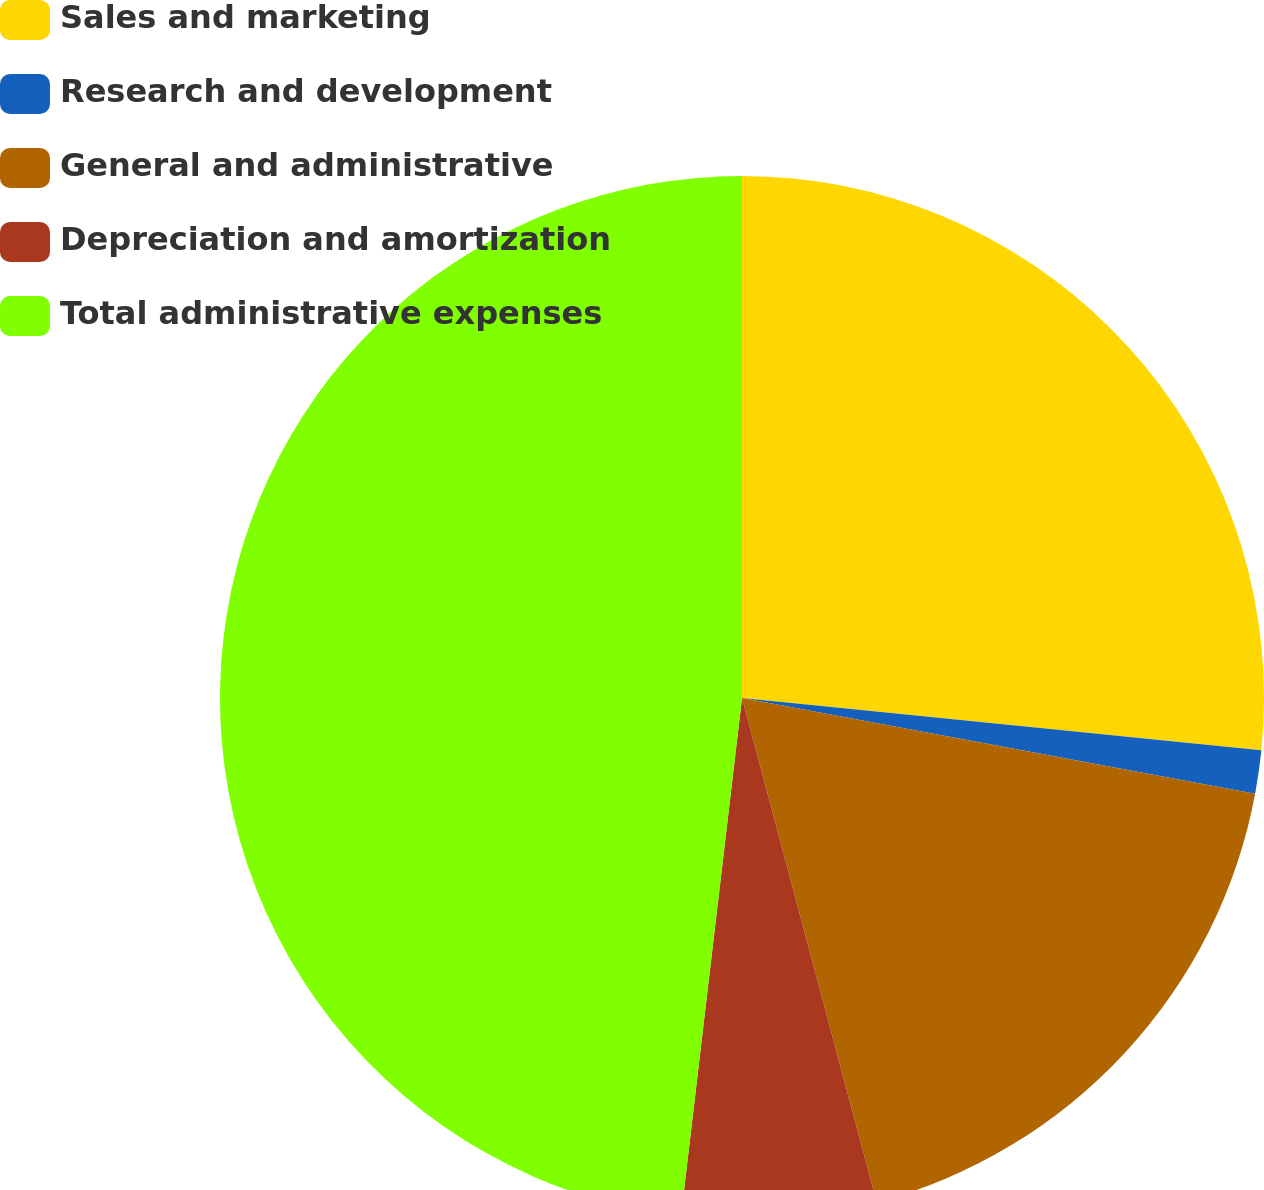Convert chart to OTSL. <chart><loc_0><loc_0><loc_500><loc_500><pie_chart><fcel>Sales and marketing<fcel>Research and development<fcel>General and administrative<fcel>Depreciation and amortization<fcel>Total administrative expenses<nl><fcel>26.6%<fcel>1.34%<fcel>17.91%<fcel>6.02%<fcel>48.14%<nl></chart> 